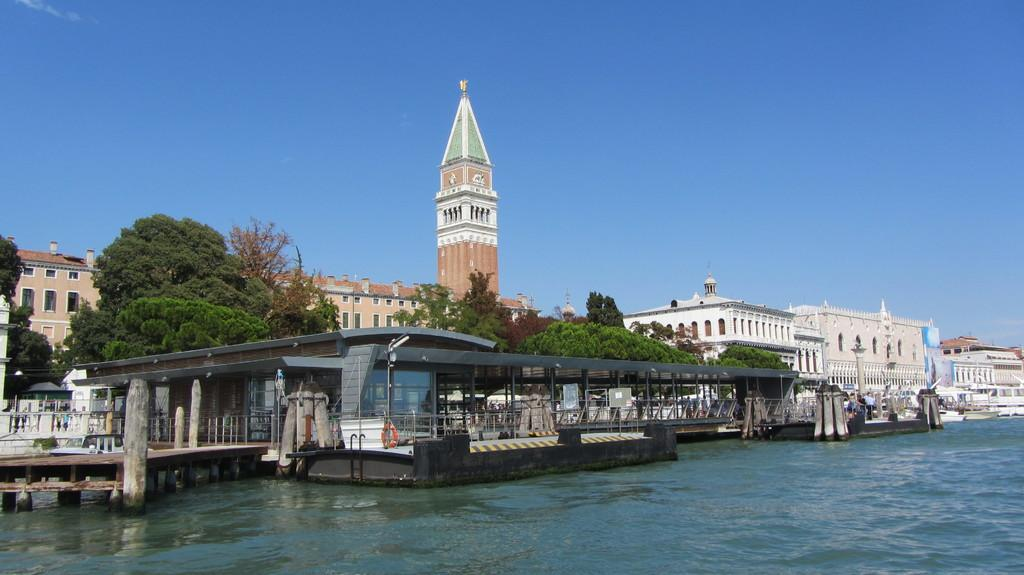What is the primary element visible in the image? There is water in the image. What structure can be seen crossing the water? There is a wooden bridge in the image. What can be seen in the distance behind the water and bridge? There are trees and buildings in the background of the image. What part of the natural environment is visible in the image? The sky is visible in the background of the image. Who is the owner of the account associated with the water in the image? There is no account or ownership information associated with the water in the image. 